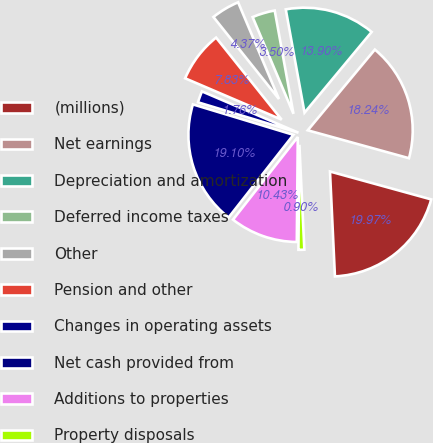Convert chart to OTSL. <chart><loc_0><loc_0><loc_500><loc_500><pie_chart><fcel>(millions)<fcel>Net earnings<fcel>Depreciation and amortization<fcel>Deferred income taxes<fcel>Other<fcel>Pension and other<fcel>Changes in operating assets<fcel>Net cash provided from<fcel>Additions to properties<fcel>Property disposals<nl><fcel>19.97%<fcel>18.24%<fcel>13.9%<fcel>3.5%<fcel>4.37%<fcel>7.83%<fcel>1.76%<fcel>19.1%<fcel>10.43%<fcel>0.9%<nl></chart> 